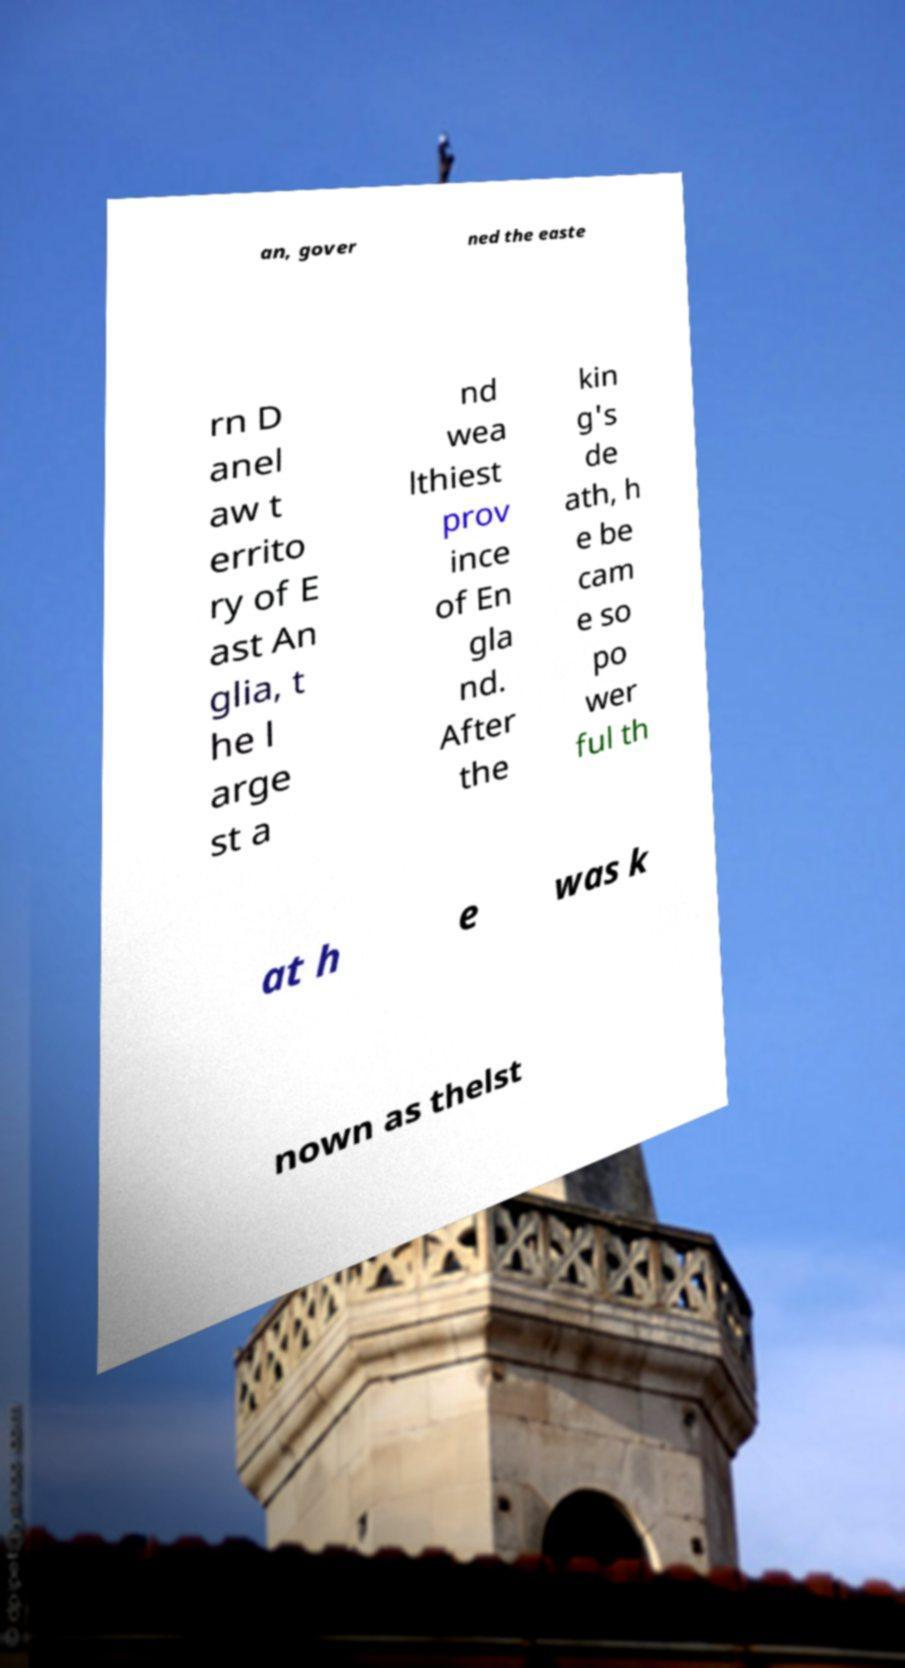There's text embedded in this image that I need extracted. Can you transcribe it verbatim? an, gover ned the easte rn D anel aw t errito ry of E ast An glia, t he l arge st a nd wea lthiest prov ince of En gla nd. After the kin g's de ath, h e be cam e so po wer ful th at h e was k nown as thelst 